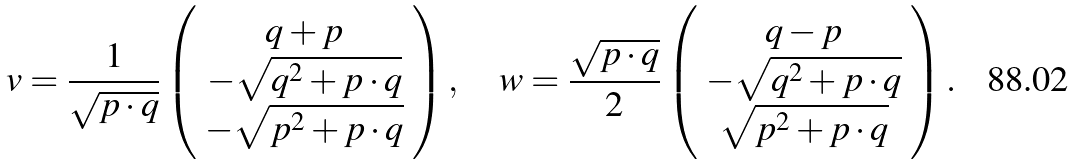Convert formula to latex. <formula><loc_0><loc_0><loc_500><loc_500>v = \frac { 1 } { \sqrt { p \cdot q } } \left ( \begin{array} { c } q + p \\ - \sqrt { q ^ { 2 } + p \cdot q } \\ - \sqrt { p ^ { 2 } + p \cdot q } \end{array} \right ) , \quad w = \frac { \sqrt { p \cdot q } } { 2 } \left ( \begin{array} { c } q - p \\ - \sqrt { q ^ { 2 } + p \cdot q } \\ \sqrt { p ^ { 2 } + p \cdot q } \end{array} \right ) .</formula> 